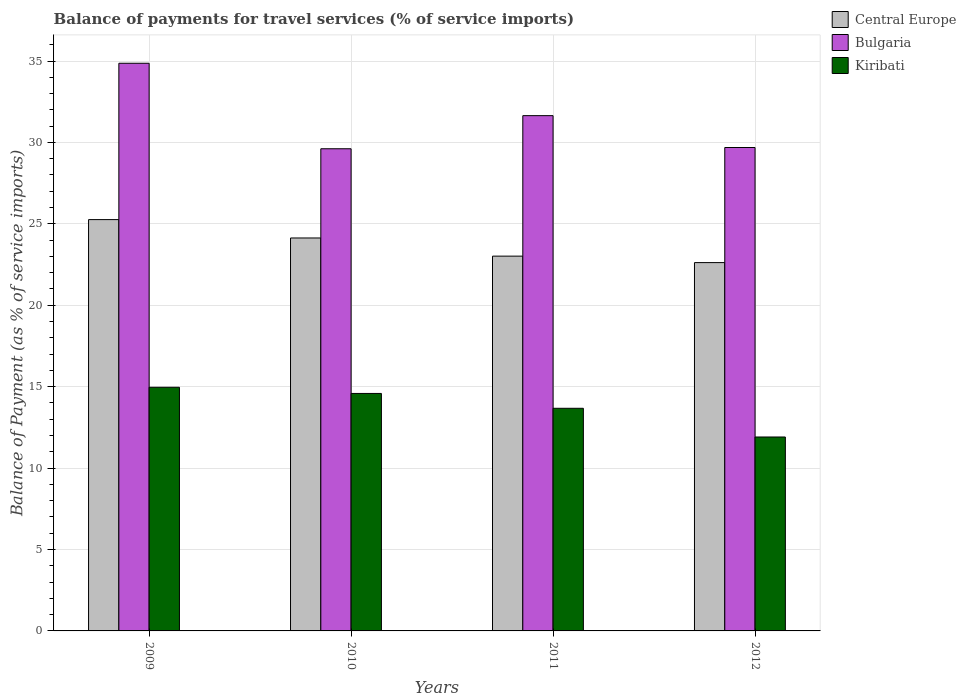Are the number of bars on each tick of the X-axis equal?
Your answer should be very brief. Yes. What is the balance of payments for travel services in Central Europe in 2011?
Provide a short and direct response. 23.02. Across all years, what is the maximum balance of payments for travel services in Bulgaria?
Give a very brief answer. 34.86. Across all years, what is the minimum balance of payments for travel services in Bulgaria?
Your response must be concise. 29.61. What is the total balance of payments for travel services in Kiribati in the graph?
Make the answer very short. 55.13. What is the difference between the balance of payments for travel services in Central Europe in 2010 and that in 2011?
Make the answer very short. 1.12. What is the difference between the balance of payments for travel services in Kiribati in 2009 and the balance of payments for travel services in Central Europe in 2012?
Ensure brevity in your answer.  -7.66. What is the average balance of payments for travel services in Bulgaria per year?
Provide a succinct answer. 31.45. In the year 2009, what is the difference between the balance of payments for travel services in Central Europe and balance of payments for travel services in Kiribati?
Offer a terse response. 10.3. What is the ratio of the balance of payments for travel services in Central Europe in 2009 to that in 2012?
Provide a succinct answer. 1.12. Is the balance of payments for travel services in Kiribati in 2011 less than that in 2012?
Your answer should be compact. No. What is the difference between the highest and the second highest balance of payments for travel services in Central Europe?
Give a very brief answer. 1.13. What is the difference between the highest and the lowest balance of payments for travel services in Central Europe?
Your response must be concise. 2.64. What does the 1st bar from the left in 2009 represents?
Ensure brevity in your answer.  Central Europe. What does the 3rd bar from the right in 2011 represents?
Offer a terse response. Central Europe. How many bars are there?
Your answer should be very brief. 12. How many years are there in the graph?
Give a very brief answer. 4. What is the difference between two consecutive major ticks on the Y-axis?
Offer a terse response. 5. What is the title of the graph?
Your answer should be compact. Balance of payments for travel services (% of service imports). Does "Europe(all income levels)" appear as one of the legend labels in the graph?
Keep it short and to the point. No. What is the label or title of the X-axis?
Provide a short and direct response. Years. What is the label or title of the Y-axis?
Your answer should be very brief. Balance of Payment (as % of service imports). What is the Balance of Payment (as % of service imports) in Central Europe in 2009?
Give a very brief answer. 25.26. What is the Balance of Payment (as % of service imports) in Bulgaria in 2009?
Keep it short and to the point. 34.86. What is the Balance of Payment (as % of service imports) of Kiribati in 2009?
Provide a succinct answer. 14.96. What is the Balance of Payment (as % of service imports) of Central Europe in 2010?
Offer a terse response. 24.13. What is the Balance of Payment (as % of service imports) of Bulgaria in 2010?
Your response must be concise. 29.61. What is the Balance of Payment (as % of service imports) in Kiribati in 2010?
Your answer should be compact. 14.58. What is the Balance of Payment (as % of service imports) of Central Europe in 2011?
Offer a terse response. 23.02. What is the Balance of Payment (as % of service imports) in Bulgaria in 2011?
Keep it short and to the point. 31.65. What is the Balance of Payment (as % of service imports) in Kiribati in 2011?
Ensure brevity in your answer.  13.67. What is the Balance of Payment (as % of service imports) in Central Europe in 2012?
Provide a short and direct response. 22.62. What is the Balance of Payment (as % of service imports) of Bulgaria in 2012?
Offer a terse response. 29.69. What is the Balance of Payment (as % of service imports) of Kiribati in 2012?
Provide a short and direct response. 11.91. Across all years, what is the maximum Balance of Payment (as % of service imports) of Central Europe?
Your answer should be very brief. 25.26. Across all years, what is the maximum Balance of Payment (as % of service imports) in Bulgaria?
Give a very brief answer. 34.86. Across all years, what is the maximum Balance of Payment (as % of service imports) of Kiribati?
Your response must be concise. 14.96. Across all years, what is the minimum Balance of Payment (as % of service imports) of Central Europe?
Offer a very short reply. 22.62. Across all years, what is the minimum Balance of Payment (as % of service imports) of Bulgaria?
Your answer should be compact. 29.61. Across all years, what is the minimum Balance of Payment (as % of service imports) in Kiribati?
Give a very brief answer. 11.91. What is the total Balance of Payment (as % of service imports) of Central Europe in the graph?
Provide a short and direct response. 95.03. What is the total Balance of Payment (as % of service imports) in Bulgaria in the graph?
Ensure brevity in your answer.  125.81. What is the total Balance of Payment (as % of service imports) in Kiribati in the graph?
Your answer should be very brief. 55.13. What is the difference between the Balance of Payment (as % of service imports) of Central Europe in 2009 and that in 2010?
Offer a terse response. 1.13. What is the difference between the Balance of Payment (as % of service imports) of Bulgaria in 2009 and that in 2010?
Provide a short and direct response. 5.25. What is the difference between the Balance of Payment (as % of service imports) of Kiribati in 2009 and that in 2010?
Offer a terse response. 0.38. What is the difference between the Balance of Payment (as % of service imports) of Central Europe in 2009 and that in 2011?
Your response must be concise. 2.24. What is the difference between the Balance of Payment (as % of service imports) of Bulgaria in 2009 and that in 2011?
Provide a succinct answer. 3.22. What is the difference between the Balance of Payment (as % of service imports) in Kiribati in 2009 and that in 2011?
Your answer should be compact. 1.29. What is the difference between the Balance of Payment (as % of service imports) of Central Europe in 2009 and that in 2012?
Your response must be concise. 2.64. What is the difference between the Balance of Payment (as % of service imports) in Bulgaria in 2009 and that in 2012?
Provide a succinct answer. 5.17. What is the difference between the Balance of Payment (as % of service imports) in Kiribati in 2009 and that in 2012?
Your answer should be very brief. 3.05. What is the difference between the Balance of Payment (as % of service imports) of Central Europe in 2010 and that in 2011?
Give a very brief answer. 1.12. What is the difference between the Balance of Payment (as % of service imports) in Bulgaria in 2010 and that in 2011?
Offer a very short reply. -2.03. What is the difference between the Balance of Payment (as % of service imports) of Kiribati in 2010 and that in 2011?
Provide a short and direct response. 0.91. What is the difference between the Balance of Payment (as % of service imports) of Central Europe in 2010 and that in 2012?
Provide a succinct answer. 1.51. What is the difference between the Balance of Payment (as % of service imports) in Bulgaria in 2010 and that in 2012?
Provide a succinct answer. -0.08. What is the difference between the Balance of Payment (as % of service imports) in Kiribati in 2010 and that in 2012?
Keep it short and to the point. 2.67. What is the difference between the Balance of Payment (as % of service imports) of Central Europe in 2011 and that in 2012?
Provide a succinct answer. 0.4. What is the difference between the Balance of Payment (as % of service imports) in Bulgaria in 2011 and that in 2012?
Keep it short and to the point. 1.96. What is the difference between the Balance of Payment (as % of service imports) of Kiribati in 2011 and that in 2012?
Ensure brevity in your answer.  1.76. What is the difference between the Balance of Payment (as % of service imports) of Central Europe in 2009 and the Balance of Payment (as % of service imports) of Bulgaria in 2010?
Your answer should be compact. -4.35. What is the difference between the Balance of Payment (as % of service imports) in Central Europe in 2009 and the Balance of Payment (as % of service imports) in Kiribati in 2010?
Your response must be concise. 10.68. What is the difference between the Balance of Payment (as % of service imports) of Bulgaria in 2009 and the Balance of Payment (as % of service imports) of Kiribati in 2010?
Your answer should be very brief. 20.28. What is the difference between the Balance of Payment (as % of service imports) of Central Europe in 2009 and the Balance of Payment (as % of service imports) of Bulgaria in 2011?
Your answer should be compact. -6.38. What is the difference between the Balance of Payment (as % of service imports) of Central Europe in 2009 and the Balance of Payment (as % of service imports) of Kiribati in 2011?
Your answer should be compact. 11.59. What is the difference between the Balance of Payment (as % of service imports) in Bulgaria in 2009 and the Balance of Payment (as % of service imports) in Kiribati in 2011?
Offer a very short reply. 21.19. What is the difference between the Balance of Payment (as % of service imports) of Central Europe in 2009 and the Balance of Payment (as % of service imports) of Bulgaria in 2012?
Provide a succinct answer. -4.43. What is the difference between the Balance of Payment (as % of service imports) in Central Europe in 2009 and the Balance of Payment (as % of service imports) in Kiribati in 2012?
Give a very brief answer. 13.35. What is the difference between the Balance of Payment (as % of service imports) of Bulgaria in 2009 and the Balance of Payment (as % of service imports) of Kiribati in 2012?
Offer a terse response. 22.95. What is the difference between the Balance of Payment (as % of service imports) in Central Europe in 2010 and the Balance of Payment (as % of service imports) in Bulgaria in 2011?
Keep it short and to the point. -7.51. What is the difference between the Balance of Payment (as % of service imports) in Central Europe in 2010 and the Balance of Payment (as % of service imports) in Kiribati in 2011?
Your answer should be compact. 10.46. What is the difference between the Balance of Payment (as % of service imports) in Bulgaria in 2010 and the Balance of Payment (as % of service imports) in Kiribati in 2011?
Your response must be concise. 15.94. What is the difference between the Balance of Payment (as % of service imports) of Central Europe in 2010 and the Balance of Payment (as % of service imports) of Bulgaria in 2012?
Your answer should be very brief. -5.56. What is the difference between the Balance of Payment (as % of service imports) in Central Europe in 2010 and the Balance of Payment (as % of service imports) in Kiribati in 2012?
Your answer should be very brief. 12.22. What is the difference between the Balance of Payment (as % of service imports) in Bulgaria in 2010 and the Balance of Payment (as % of service imports) in Kiribati in 2012?
Give a very brief answer. 17.7. What is the difference between the Balance of Payment (as % of service imports) of Central Europe in 2011 and the Balance of Payment (as % of service imports) of Bulgaria in 2012?
Your response must be concise. -6.67. What is the difference between the Balance of Payment (as % of service imports) of Central Europe in 2011 and the Balance of Payment (as % of service imports) of Kiribati in 2012?
Ensure brevity in your answer.  11.11. What is the difference between the Balance of Payment (as % of service imports) of Bulgaria in 2011 and the Balance of Payment (as % of service imports) of Kiribati in 2012?
Keep it short and to the point. 19.74. What is the average Balance of Payment (as % of service imports) of Central Europe per year?
Provide a short and direct response. 23.76. What is the average Balance of Payment (as % of service imports) of Bulgaria per year?
Your response must be concise. 31.45. What is the average Balance of Payment (as % of service imports) in Kiribati per year?
Ensure brevity in your answer.  13.78. In the year 2009, what is the difference between the Balance of Payment (as % of service imports) in Central Europe and Balance of Payment (as % of service imports) in Bulgaria?
Provide a succinct answer. -9.6. In the year 2009, what is the difference between the Balance of Payment (as % of service imports) of Central Europe and Balance of Payment (as % of service imports) of Kiribati?
Offer a terse response. 10.3. In the year 2009, what is the difference between the Balance of Payment (as % of service imports) in Bulgaria and Balance of Payment (as % of service imports) in Kiribati?
Offer a terse response. 19.9. In the year 2010, what is the difference between the Balance of Payment (as % of service imports) in Central Europe and Balance of Payment (as % of service imports) in Bulgaria?
Your answer should be very brief. -5.48. In the year 2010, what is the difference between the Balance of Payment (as % of service imports) in Central Europe and Balance of Payment (as % of service imports) in Kiribati?
Your answer should be compact. 9.55. In the year 2010, what is the difference between the Balance of Payment (as % of service imports) of Bulgaria and Balance of Payment (as % of service imports) of Kiribati?
Keep it short and to the point. 15.03. In the year 2011, what is the difference between the Balance of Payment (as % of service imports) of Central Europe and Balance of Payment (as % of service imports) of Bulgaria?
Provide a succinct answer. -8.63. In the year 2011, what is the difference between the Balance of Payment (as % of service imports) in Central Europe and Balance of Payment (as % of service imports) in Kiribati?
Keep it short and to the point. 9.34. In the year 2011, what is the difference between the Balance of Payment (as % of service imports) in Bulgaria and Balance of Payment (as % of service imports) in Kiribati?
Offer a terse response. 17.97. In the year 2012, what is the difference between the Balance of Payment (as % of service imports) of Central Europe and Balance of Payment (as % of service imports) of Bulgaria?
Give a very brief answer. -7.07. In the year 2012, what is the difference between the Balance of Payment (as % of service imports) in Central Europe and Balance of Payment (as % of service imports) in Kiribati?
Your answer should be very brief. 10.71. In the year 2012, what is the difference between the Balance of Payment (as % of service imports) in Bulgaria and Balance of Payment (as % of service imports) in Kiribati?
Your answer should be very brief. 17.78. What is the ratio of the Balance of Payment (as % of service imports) in Central Europe in 2009 to that in 2010?
Provide a succinct answer. 1.05. What is the ratio of the Balance of Payment (as % of service imports) of Bulgaria in 2009 to that in 2010?
Offer a terse response. 1.18. What is the ratio of the Balance of Payment (as % of service imports) in Central Europe in 2009 to that in 2011?
Your answer should be very brief. 1.1. What is the ratio of the Balance of Payment (as % of service imports) of Bulgaria in 2009 to that in 2011?
Your answer should be compact. 1.1. What is the ratio of the Balance of Payment (as % of service imports) of Kiribati in 2009 to that in 2011?
Ensure brevity in your answer.  1.09. What is the ratio of the Balance of Payment (as % of service imports) of Central Europe in 2009 to that in 2012?
Keep it short and to the point. 1.12. What is the ratio of the Balance of Payment (as % of service imports) in Bulgaria in 2009 to that in 2012?
Your answer should be compact. 1.17. What is the ratio of the Balance of Payment (as % of service imports) of Kiribati in 2009 to that in 2012?
Ensure brevity in your answer.  1.26. What is the ratio of the Balance of Payment (as % of service imports) of Central Europe in 2010 to that in 2011?
Your answer should be very brief. 1.05. What is the ratio of the Balance of Payment (as % of service imports) of Bulgaria in 2010 to that in 2011?
Your answer should be compact. 0.94. What is the ratio of the Balance of Payment (as % of service imports) of Kiribati in 2010 to that in 2011?
Your answer should be very brief. 1.07. What is the ratio of the Balance of Payment (as % of service imports) of Central Europe in 2010 to that in 2012?
Keep it short and to the point. 1.07. What is the ratio of the Balance of Payment (as % of service imports) of Kiribati in 2010 to that in 2012?
Make the answer very short. 1.22. What is the ratio of the Balance of Payment (as % of service imports) of Central Europe in 2011 to that in 2012?
Ensure brevity in your answer.  1.02. What is the ratio of the Balance of Payment (as % of service imports) of Bulgaria in 2011 to that in 2012?
Your answer should be very brief. 1.07. What is the ratio of the Balance of Payment (as % of service imports) of Kiribati in 2011 to that in 2012?
Your answer should be very brief. 1.15. What is the difference between the highest and the second highest Balance of Payment (as % of service imports) in Central Europe?
Offer a very short reply. 1.13. What is the difference between the highest and the second highest Balance of Payment (as % of service imports) in Bulgaria?
Keep it short and to the point. 3.22. What is the difference between the highest and the second highest Balance of Payment (as % of service imports) in Kiribati?
Your answer should be very brief. 0.38. What is the difference between the highest and the lowest Balance of Payment (as % of service imports) in Central Europe?
Keep it short and to the point. 2.64. What is the difference between the highest and the lowest Balance of Payment (as % of service imports) in Bulgaria?
Provide a short and direct response. 5.25. What is the difference between the highest and the lowest Balance of Payment (as % of service imports) of Kiribati?
Make the answer very short. 3.05. 